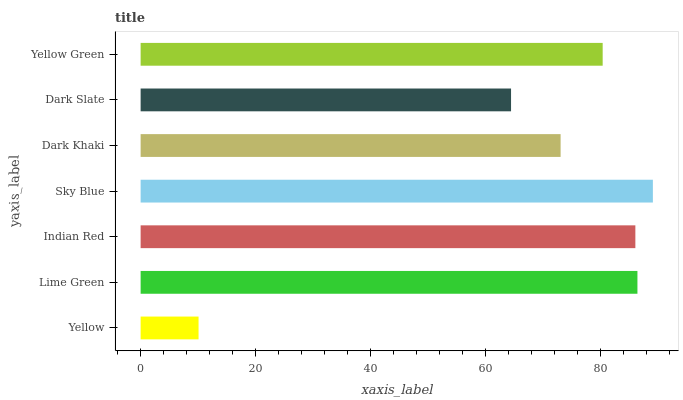Is Yellow the minimum?
Answer yes or no. Yes. Is Sky Blue the maximum?
Answer yes or no. Yes. Is Lime Green the minimum?
Answer yes or no. No. Is Lime Green the maximum?
Answer yes or no. No. Is Lime Green greater than Yellow?
Answer yes or no. Yes. Is Yellow less than Lime Green?
Answer yes or no. Yes. Is Yellow greater than Lime Green?
Answer yes or no. No. Is Lime Green less than Yellow?
Answer yes or no. No. Is Yellow Green the high median?
Answer yes or no. Yes. Is Yellow Green the low median?
Answer yes or no. Yes. Is Yellow the high median?
Answer yes or no. No. Is Dark Khaki the low median?
Answer yes or no. No. 